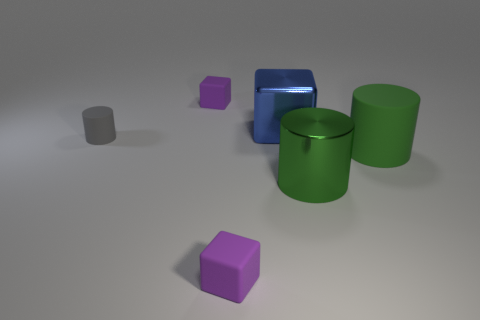Add 2 gray cylinders. How many objects exist? 8 Add 3 tiny purple rubber cubes. How many tiny purple rubber cubes exist? 5 Subtract 0 brown cylinders. How many objects are left? 6 Subtract all gray things. Subtract all big shiny objects. How many objects are left? 3 Add 6 small purple rubber things. How many small purple rubber things are left? 8 